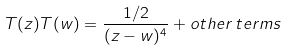<formula> <loc_0><loc_0><loc_500><loc_500>T ( z ) T ( w ) = \frac { 1 / 2 } { ( z - w ) ^ { 4 } } + o t h e r \, t e r m s</formula> 